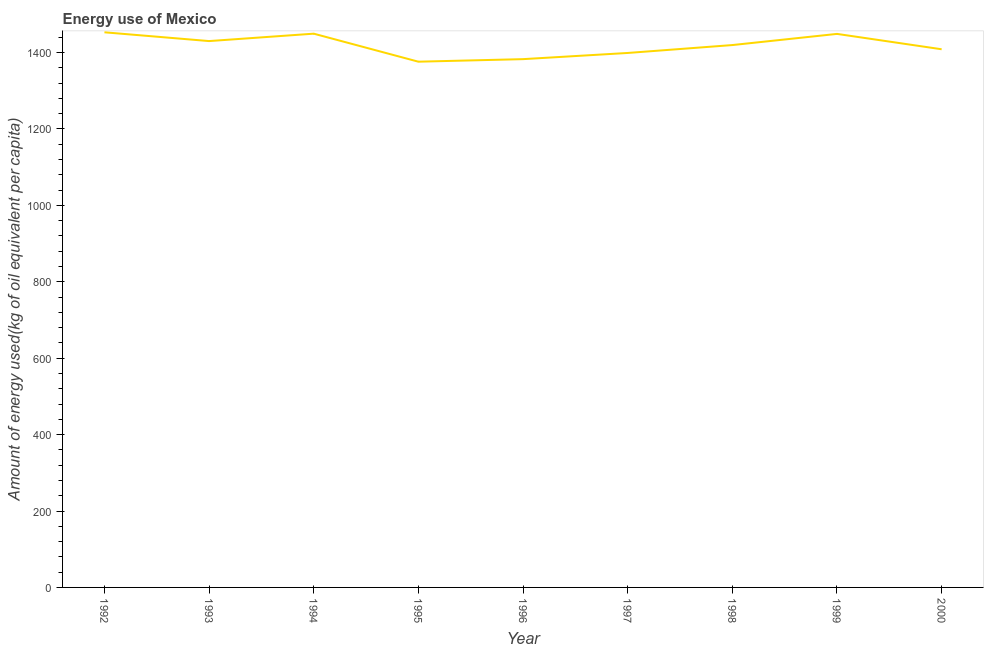What is the amount of energy used in 1996?
Provide a succinct answer. 1382.72. Across all years, what is the maximum amount of energy used?
Provide a succinct answer. 1452.97. Across all years, what is the minimum amount of energy used?
Your answer should be compact. 1376.02. In which year was the amount of energy used maximum?
Your answer should be very brief. 1992. In which year was the amount of energy used minimum?
Offer a terse response. 1995. What is the sum of the amount of energy used?
Provide a short and direct response. 1.28e+04. What is the difference between the amount of energy used in 1992 and 1998?
Offer a terse response. 33.42. What is the average amount of energy used per year?
Your answer should be very brief. 1418.54. What is the median amount of energy used?
Offer a very short reply. 1419.55. Do a majority of the years between 1998 and 1993 (inclusive) have amount of energy used greater than 680 kg?
Your answer should be very brief. Yes. What is the ratio of the amount of energy used in 1992 to that in 1999?
Offer a terse response. 1. Is the amount of energy used in 1992 less than that in 2000?
Provide a succinct answer. No. Is the difference between the amount of energy used in 1995 and 2000 greater than the difference between any two years?
Give a very brief answer. No. What is the difference between the highest and the second highest amount of energy used?
Ensure brevity in your answer.  3.61. Is the sum of the amount of energy used in 1992 and 1998 greater than the maximum amount of energy used across all years?
Keep it short and to the point. Yes. What is the difference between the highest and the lowest amount of energy used?
Provide a succinct answer. 76.95. In how many years, is the amount of energy used greater than the average amount of energy used taken over all years?
Offer a very short reply. 5. Does the amount of energy used monotonically increase over the years?
Provide a short and direct response. No. How many lines are there?
Give a very brief answer. 1. What is the difference between two consecutive major ticks on the Y-axis?
Your response must be concise. 200. What is the title of the graph?
Offer a very short reply. Energy use of Mexico. What is the label or title of the Y-axis?
Your answer should be very brief. Amount of energy used(kg of oil equivalent per capita). What is the Amount of energy used(kg of oil equivalent per capita) in 1992?
Keep it short and to the point. 1452.97. What is the Amount of energy used(kg of oil equivalent per capita) in 1993?
Make the answer very short. 1429.97. What is the Amount of energy used(kg of oil equivalent per capita) in 1994?
Provide a succinct answer. 1449.36. What is the Amount of energy used(kg of oil equivalent per capita) in 1995?
Your answer should be very brief. 1376.02. What is the Amount of energy used(kg of oil equivalent per capita) in 1996?
Your response must be concise. 1382.72. What is the Amount of energy used(kg of oil equivalent per capita) in 1997?
Offer a very short reply. 1398.88. What is the Amount of energy used(kg of oil equivalent per capita) of 1998?
Your answer should be compact. 1419.55. What is the Amount of energy used(kg of oil equivalent per capita) in 1999?
Give a very brief answer. 1448.78. What is the Amount of energy used(kg of oil equivalent per capita) of 2000?
Offer a very short reply. 1408.56. What is the difference between the Amount of energy used(kg of oil equivalent per capita) in 1992 and 1993?
Provide a short and direct response. 23. What is the difference between the Amount of energy used(kg of oil equivalent per capita) in 1992 and 1994?
Offer a terse response. 3.61. What is the difference between the Amount of energy used(kg of oil equivalent per capita) in 1992 and 1995?
Your response must be concise. 76.95. What is the difference between the Amount of energy used(kg of oil equivalent per capita) in 1992 and 1996?
Your response must be concise. 70.25. What is the difference between the Amount of energy used(kg of oil equivalent per capita) in 1992 and 1997?
Ensure brevity in your answer.  54.09. What is the difference between the Amount of energy used(kg of oil equivalent per capita) in 1992 and 1998?
Your answer should be very brief. 33.42. What is the difference between the Amount of energy used(kg of oil equivalent per capita) in 1992 and 1999?
Ensure brevity in your answer.  4.19. What is the difference between the Amount of energy used(kg of oil equivalent per capita) in 1992 and 2000?
Give a very brief answer. 44.42. What is the difference between the Amount of energy used(kg of oil equivalent per capita) in 1993 and 1994?
Make the answer very short. -19.38. What is the difference between the Amount of energy used(kg of oil equivalent per capita) in 1993 and 1995?
Your answer should be compact. 53.95. What is the difference between the Amount of energy used(kg of oil equivalent per capita) in 1993 and 1996?
Ensure brevity in your answer.  47.25. What is the difference between the Amount of energy used(kg of oil equivalent per capita) in 1993 and 1997?
Make the answer very short. 31.09. What is the difference between the Amount of energy used(kg of oil equivalent per capita) in 1993 and 1998?
Provide a short and direct response. 10.42. What is the difference between the Amount of energy used(kg of oil equivalent per capita) in 1993 and 1999?
Offer a very short reply. -18.81. What is the difference between the Amount of energy used(kg of oil equivalent per capita) in 1993 and 2000?
Your response must be concise. 21.42. What is the difference between the Amount of energy used(kg of oil equivalent per capita) in 1994 and 1995?
Offer a terse response. 73.33. What is the difference between the Amount of energy used(kg of oil equivalent per capita) in 1994 and 1996?
Your answer should be compact. 66.64. What is the difference between the Amount of energy used(kg of oil equivalent per capita) in 1994 and 1997?
Provide a succinct answer. 50.47. What is the difference between the Amount of energy used(kg of oil equivalent per capita) in 1994 and 1998?
Your response must be concise. 29.81. What is the difference between the Amount of energy used(kg of oil equivalent per capita) in 1994 and 1999?
Offer a very short reply. 0.58. What is the difference between the Amount of energy used(kg of oil equivalent per capita) in 1994 and 2000?
Provide a succinct answer. 40.8. What is the difference between the Amount of energy used(kg of oil equivalent per capita) in 1995 and 1996?
Make the answer very short. -6.69. What is the difference between the Amount of energy used(kg of oil equivalent per capita) in 1995 and 1997?
Your answer should be very brief. -22.86. What is the difference between the Amount of energy used(kg of oil equivalent per capita) in 1995 and 1998?
Provide a short and direct response. -43.53. What is the difference between the Amount of energy used(kg of oil equivalent per capita) in 1995 and 1999?
Provide a succinct answer. -72.76. What is the difference between the Amount of energy used(kg of oil equivalent per capita) in 1995 and 2000?
Provide a succinct answer. -32.53. What is the difference between the Amount of energy used(kg of oil equivalent per capita) in 1996 and 1997?
Your answer should be very brief. -16.17. What is the difference between the Amount of energy used(kg of oil equivalent per capita) in 1996 and 1998?
Your answer should be very brief. -36.83. What is the difference between the Amount of energy used(kg of oil equivalent per capita) in 1996 and 1999?
Offer a very short reply. -66.06. What is the difference between the Amount of energy used(kg of oil equivalent per capita) in 1996 and 2000?
Make the answer very short. -25.84. What is the difference between the Amount of energy used(kg of oil equivalent per capita) in 1997 and 1998?
Your answer should be very brief. -20.67. What is the difference between the Amount of energy used(kg of oil equivalent per capita) in 1997 and 1999?
Provide a succinct answer. -49.9. What is the difference between the Amount of energy used(kg of oil equivalent per capita) in 1997 and 2000?
Make the answer very short. -9.67. What is the difference between the Amount of energy used(kg of oil equivalent per capita) in 1998 and 1999?
Provide a short and direct response. -29.23. What is the difference between the Amount of energy used(kg of oil equivalent per capita) in 1998 and 2000?
Your response must be concise. 11. What is the difference between the Amount of energy used(kg of oil equivalent per capita) in 1999 and 2000?
Your answer should be very brief. 40.22. What is the ratio of the Amount of energy used(kg of oil equivalent per capita) in 1992 to that in 1995?
Provide a short and direct response. 1.06. What is the ratio of the Amount of energy used(kg of oil equivalent per capita) in 1992 to that in 1996?
Make the answer very short. 1.05. What is the ratio of the Amount of energy used(kg of oil equivalent per capita) in 1992 to that in 1997?
Provide a short and direct response. 1.04. What is the ratio of the Amount of energy used(kg of oil equivalent per capita) in 1992 to that in 1998?
Offer a terse response. 1.02. What is the ratio of the Amount of energy used(kg of oil equivalent per capita) in 1992 to that in 1999?
Provide a short and direct response. 1. What is the ratio of the Amount of energy used(kg of oil equivalent per capita) in 1992 to that in 2000?
Give a very brief answer. 1.03. What is the ratio of the Amount of energy used(kg of oil equivalent per capita) in 1993 to that in 1994?
Keep it short and to the point. 0.99. What is the ratio of the Amount of energy used(kg of oil equivalent per capita) in 1993 to that in 1995?
Give a very brief answer. 1.04. What is the ratio of the Amount of energy used(kg of oil equivalent per capita) in 1993 to that in 1996?
Ensure brevity in your answer.  1.03. What is the ratio of the Amount of energy used(kg of oil equivalent per capita) in 1993 to that in 1997?
Your answer should be compact. 1.02. What is the ratio of the Amount of energy used(kg of oil equivalent per capita) in 1993 to that in 1998?
Offer a terse response. 1.01. What is the ratio of the Amount of energy used(kg of oil equivalent per capita) in 1994 to that in 1995?
Offer a terse response. 1.05. What is the ratio of the Amount of energy used(kg of oil equivalent per capita) in 1994 to that in 1996?
Offer a very short reply. 1.05. What is the ratio of the Amount of energy used(kg of oil equivalent per capita) in 1994 to that in 1997?
Provide a short and direct response. 1.04. What is the ratio of the Amount of energy used(kg of oil equivalent per capita) in 1994 to that in 1998?
Keep it short and to the point. 1.02. What is the ratio of the Amount of energy used(kg of oil equivalent per capita) in 1994 to that in 1999?
Offer a terse response. 1. What is the ratio of the Amount of energy used(kg of oil equivalent per capita) in 1994 to that in 2000?
Offer a very short reply. 1.03. What is the ratio of the Amount of energy used(kg of oil equivalent per capita) in 1995 to that in 1996?
Your response must be concise. 0.99. What is the ratio of the Amount of energy used(kg of oil equivalent per capita) in 1995 to that in 1997?
Ensure brevity in your answer.  0.98. What is the ratio of the Amount of energy used(kg of oil equivalent per capita) in 1995 to that in 1998?
Keep it short and to the point. 0.97. What is the ratio of the Amount of energy used(kg of oil equivalent per capita) in 1995 to that in 1999?
Your response must be concise. 0.95. What is the ratio of the Amount of energy used(kg of oil equivalent per capita) in 1996 to that in 1999?
Your answer should be compact. 0.95. What is the ratio of the Amount of energy used(kg of oil equivalent per capita) in 1997 to that in 2000?
Ensure brevity in your answer.  0.99. What is the ratio of the Amount of energy used(kg of oil equivalent per capita) in 1998 to that in 1999?
Your answer should be very brief. 0.98. What is the ratio of the Amount of energy used(kg of oil equivalent per capita) in 1998 to that in 2000?
Your answer should be compact. 1.01. 